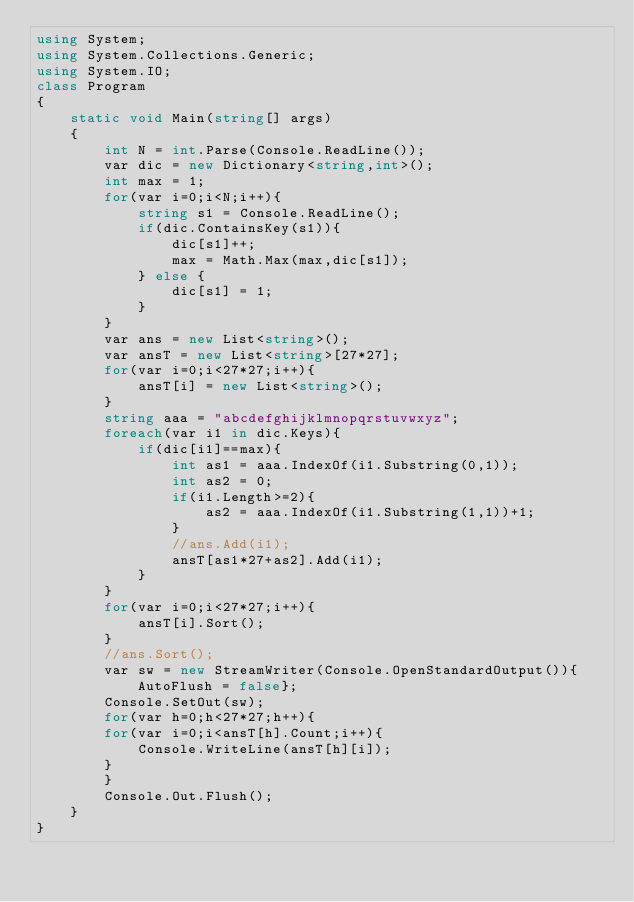<code> <loc_0><loc_0><loc_500><loc_500><_C#_>using System;
using System.Collections.Generic;
using System.IO;
class Program
{
	static void Main(string[] args)
	{
		int N = int.Parse(Console.ReadLine());
		var dic = new Dictionary<string,int>();
		int max = 1;
		for(var i=0;i<N;i++){
			string s1 = Console.ReadLine();
			if(dic.ContainsKey(s1)){
				dic[s1]++;
				max = Math.Max(max,dic[s1]);
			} else {
				dic[s1] = 1;
			}
		}
		var ans = new List<string>();
		var ansT = new List<string>[27*27];
		for(var i=0;i<27*27;i++){
          	ansT[i] = new List<string>();
        }
		string aaa = "abcdefghijklmnopqrstuvwxyz";
		foreach(var i1 in dic.Keys){
			if(dic[i1]==max){
				int as1 = aaa.IndexOf(i1.Substring(0,1));
				int as2 = 0;
				if(i1.Length>=2){
                  	as2 = aaa.IndexOf(i1.Substring(1,1))+1;
                }
				//ans.Add(i1);
				ansT[as1*27+as2].Add(i1);
			}
		}
		for(var i=0;i<27*27;i++){
          	ansT[i].Sort();
        }
		//ans.Sort();
		var sw = new StreamWriter(Console.OpenStandardOutput()){AutoFlush = false};
		Console.SetOut(sw);
      	for(var h=0;h<27*27;h++){
		for(var i=0;i<ansT[h].Count;i++){
			Console.WriteLine(ansT[h][i]);
		}
        }
		Console.Out.Flush();
	}
}
</code> 